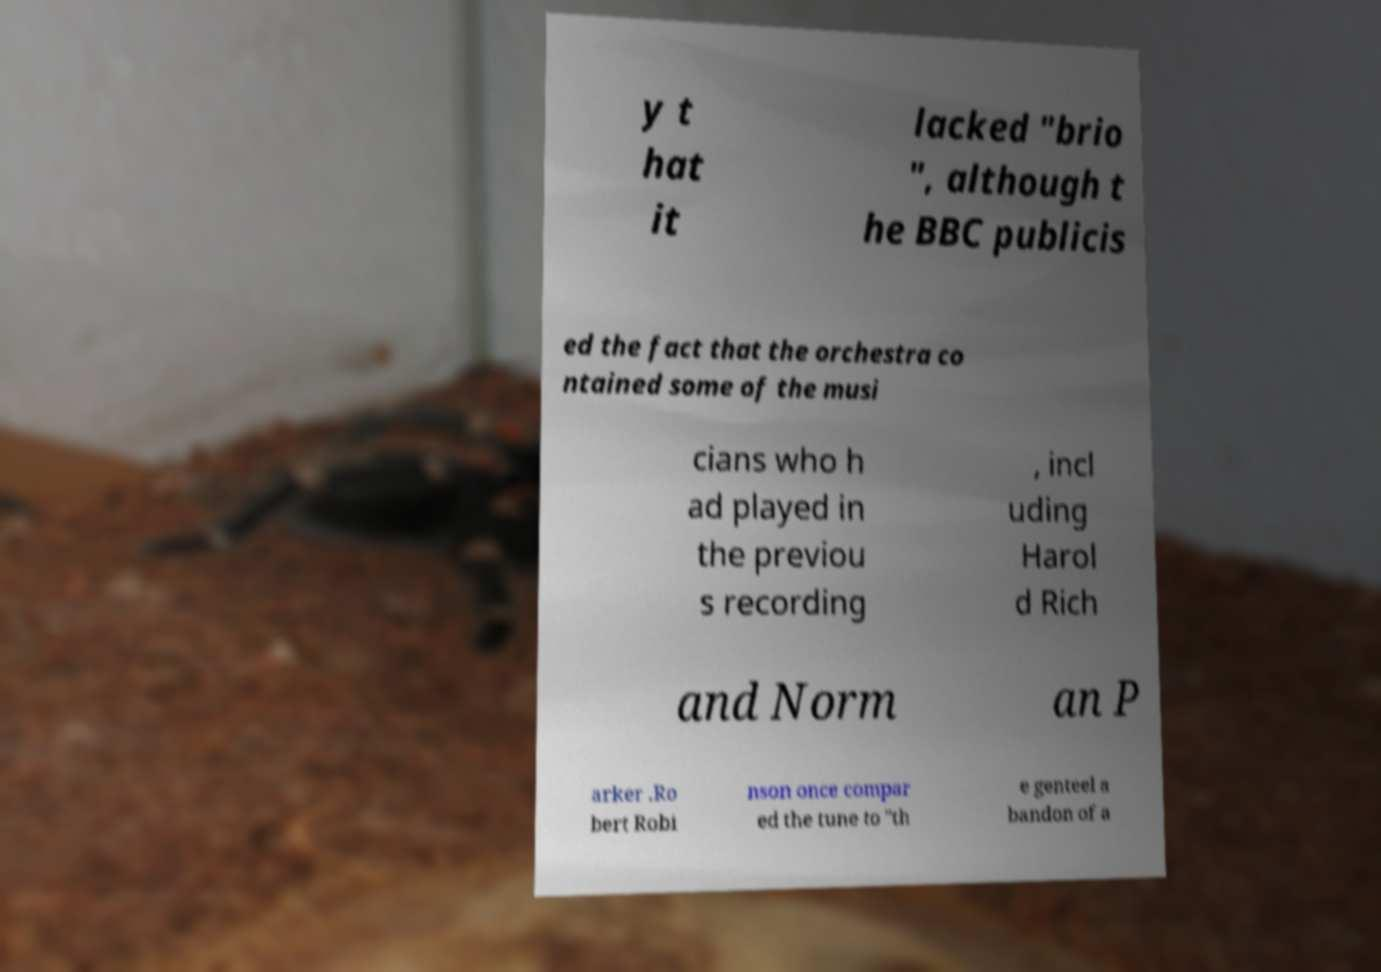There's text embedded in this image that I need extracted. Can you transcribe it verbatim? y t hat it lacked "brio ", although t he BBC publicis ed the fact that the orchestra co ntained some of the musi cians who h ad played in the previou s recording , incl uding Harol d Rich and Norm an P arker .Ro bert Robi nson once compar ed the tune to "th e genteel a bandon of a 